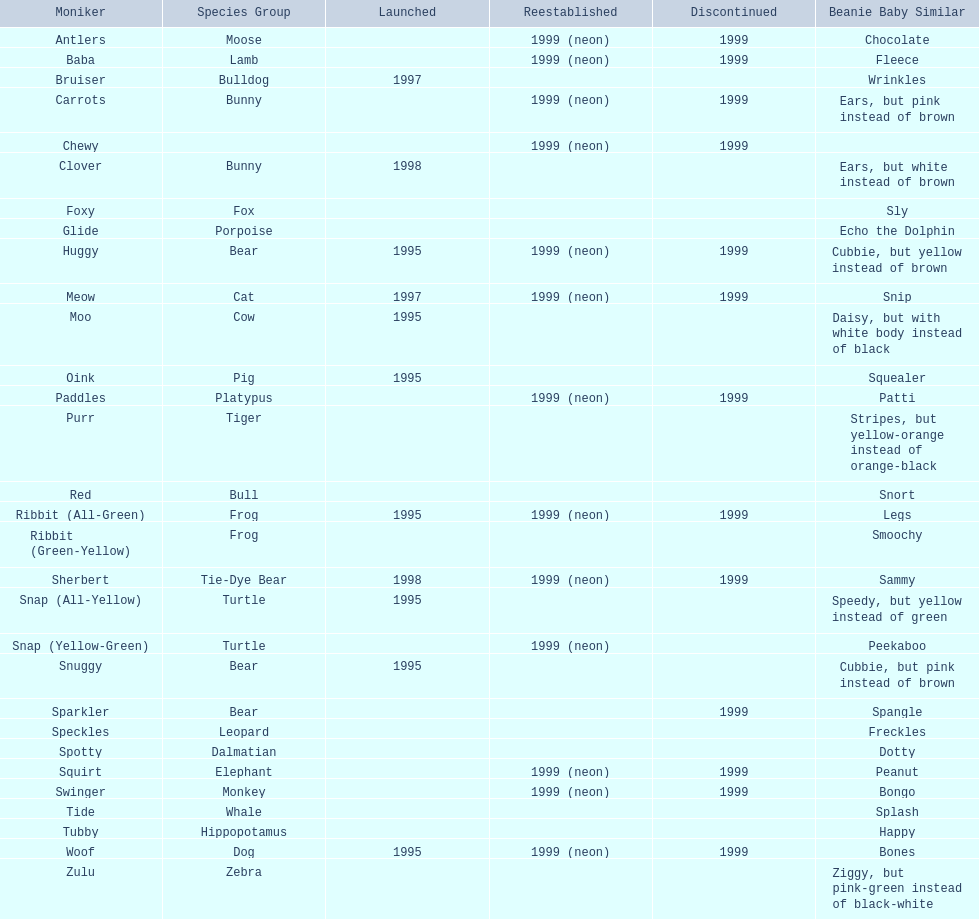How many monkey pillow pals were there? 1. 